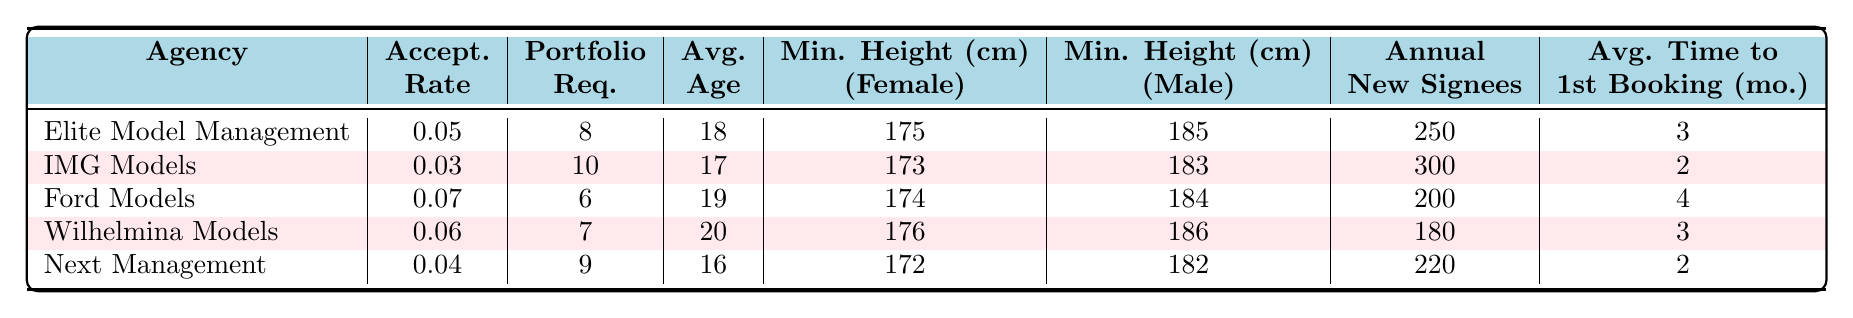What is the acceptance rate for IMG Models? The table lists the acceptance rates for each agency. For IMG Models, the acceptance rate is 0.03.
Answer: 0.03 How many portfolio requirements does Elite Model Management have? The table shows that Elite Model Management has 8 portfolio requirements.
Answer: 8 What is the average age of accepted models at Next Management? The average age of accepted models at Next Management is listed in the table as 16.
Answer: 16 Which agency has the highest acceptance rate? By reviewing the acceptance rates in the table, Ford Models has the highest rate of 0.07.
Answer: Ford Models What is the minimum height requirement for female models at Wilhelmina Models? The minimum height requirement for female models at Wilhelmina Models is 176 cm, as indicated in the table.
Answer: 176 cm If I combine the minimum heights required for female models at all agencies, what is the total? I will sum the minimum heights: 175 + 173 + 174 + 176 + 172 = 870 cm.
Answer: 870 cm Is the average time to first booking shorter for IMG Models than for Ford Models? The average time for IMG Models is 2 months, while for Ford Models it is 4 months. Therefore, yes, IMG Models has a shorter time.
Answer: Yes Which agency requires the most portfolio pieces and what is the acceptance rate? The agency with the most portfolios required is IMG Models with 10 pieces, and the acceptance rate is 0.03.
Answer: IMG Models, 0.03 What is the difference in annual new signees between Ford Models and Elite Model Management? Ford Models has 200 annual new signees, and Elite Model Management has 250. The difference is 250 - 200 = 50.
Answer: 50 Can we conclude that younger models are generally accepted by agencies with longer average time to first booking? To analyze this, we look at the average ages and average times to first booking: Wilhelmina (20, 3), IMG (17, 2), Ford (19, 4), Elite (18, 3), Next (16, 2). There’s no clear trend as both younger and older models face varying times.
Answer: No 